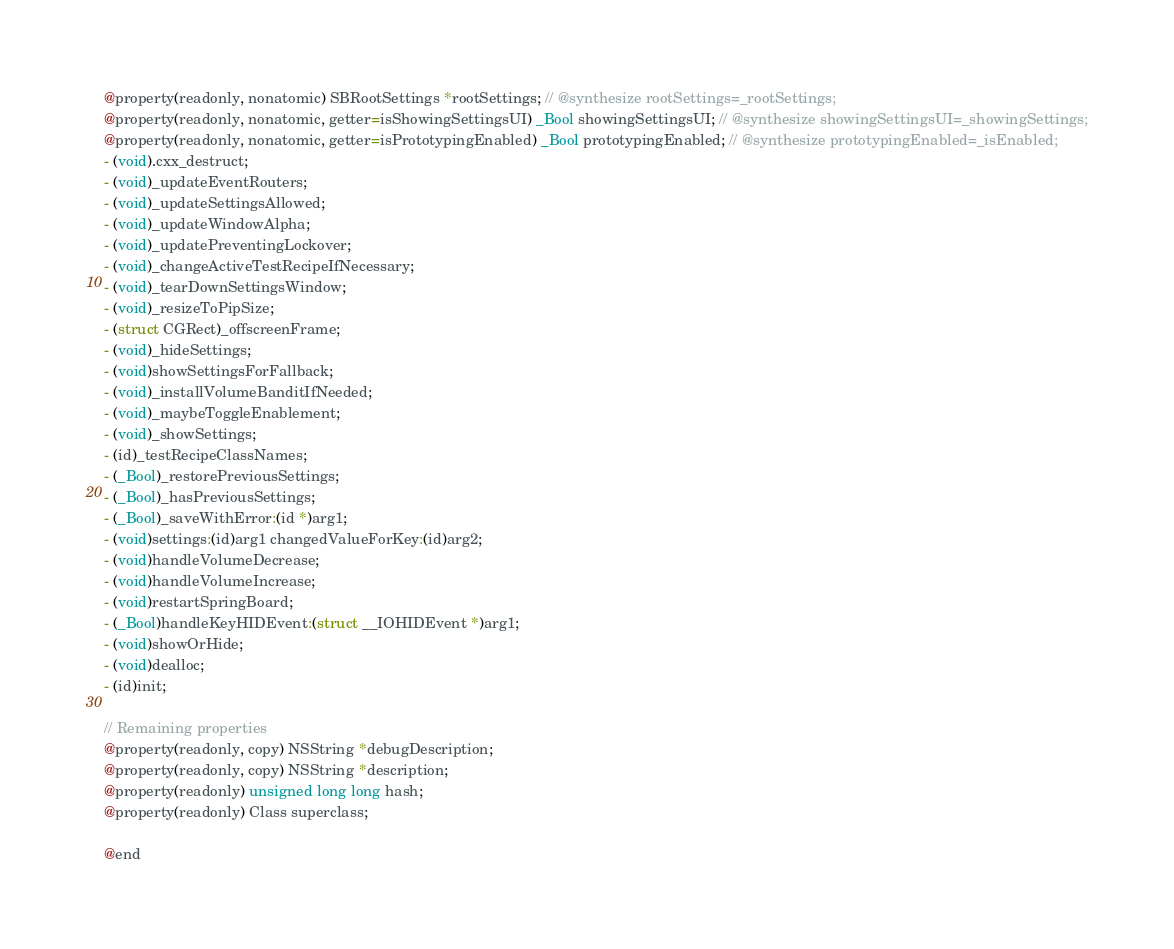<code> <loc_0><loc_0><loc_500><loc_500><_C_>@property(readonly, nonatomic) SBRootSettings *rootSettings; // @synthesize rootSettings=_rootSettings;
@property(readonly, nonatomic, getter=isShowingSettingsUI) _Bool showingSettingsUI; // @synthesize showingSettingsUI=_showingSettings;
@property(readonly, nonatomic, getter=isPrototypingEnabled) _Bool prototypingEnabled; // @synthesize prototypingEnabled=_isEnabled;
- (void).cxx_destruct;
- (void)_updateEventRouters;
- (void)_updateSettingsAllowed;
- (void)_updateWindowAlpha;
- (void)_updatePreventingLockover;
- (void)_changeActiveTestRecipeIfNecessary;
- (void)_tearDownSettingsWindow;
- (void)_resizeToPipSize;
- (struct CGRect)_offscreenFrame;
- (void)_hideSettings;
- (void)showSettingsForFallback;
- (void)_installVolumeBanditIfNeeded;
- (void)_maybeToggleEnablement;
- (void)_showSettings;
- (id)_testRecipeClassNames;
- (_Bool)_restorePreviousSettings;
- (_Bool)_hasPreviousSettings;
- (_Bool)_saveWithError:(id *)arg1;
- (void)settings:(id)arg1 changedValueForKey:(id)arg2;
- (void)handleVolumeDecrease;
- (void)handleVolumeIncrease;
- (void)restartSpringBoard;
- (_Bool)handleKeyHIDEvent:(struct __IOHIDEvent *)arg1;
- (void)showOrHide;
- (void)dealloc;
- (id)init;

// Remaining properties
@property(readonly, copy) NSString *debugDescription;
@property(readonly, copy) NSString *description;
@property(readonly) unsigned long long hash;
@property(readonly) Class superclass;

@end

</code> 